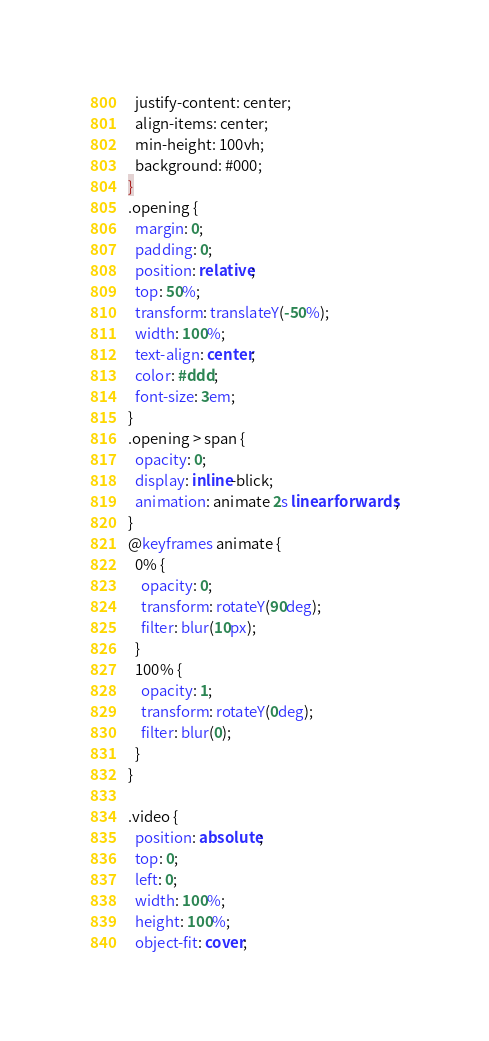<code> <loc_0><loc_0><loc_500><loc_500><_CSS_>  justify-content: center;
  align-items: center;
  min-height: 100vh;
  background: #000;
}
.opening {
  margin: 0;
  padding: 0;
  position: relative;
  top: 50%;
  transform: translateY(-50%);
  width: 100%;
  text-align: center;
  color: #ddd;
  font-size: 3em;
}
.opening > span {
  opacity: 0;
  display: inline-blick;
  animation: animate 2s linear forwards;
}
@keyframes animate {
  0% {
    opacity: 0;
    transform: rotateY(90deg);
    filter: blur(10px);
  }
  100% {
    opacity: 1;
    transform: rotateY(0deg);
    filter: blur(0);
  }
}

.video {
  position: absolute;
  top: 0;
  left: 0;
  width: 100%;
  height: 100%;
  object-fit: cover;</code> 